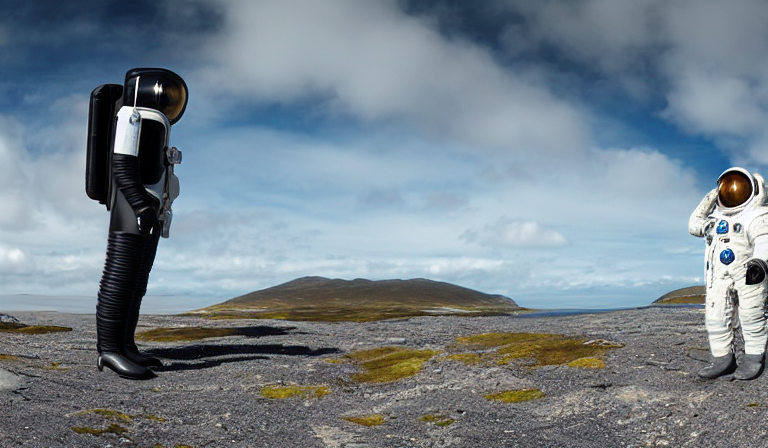What do you think the camera-headed figure symbolizes? The camera-headed figure could symbolize the idea that as explorers and observers, our view of the world is often mediated through technology. It reflects how our experiences, memories, and even our presence in new places are frequently documented through the lens of a camera, potentially commenting on the transformation of perception in the digital age. 